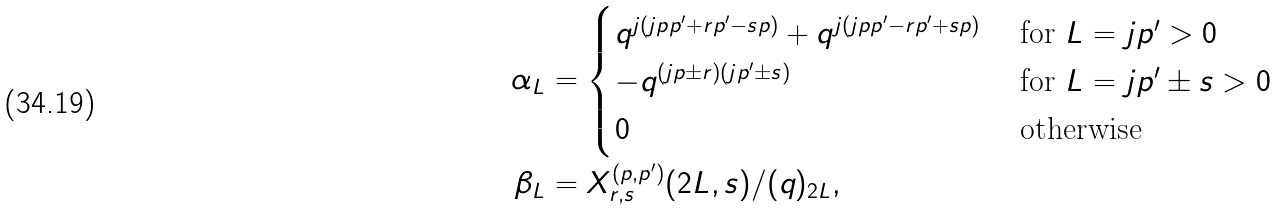Convert formula to latex. <formula><loc_0><loc_0><loc_500><loc_500>\alpha _ { L } & = \begin{cases} q ^ { j ( j p p ^ { \prime } + r p ^ { \prime } - s p ) } + q ^ { j ( j p p ^ { \prime } - r p ^ { \prime } + s p ) } & \text { for $L=jp^{\prime}>0$} \\ - q ^ { ( j p \pm r ) ( j p ^ { \prime } \pm s ) } & \text { for $L=jp^{\prime}\pm s>0$} \\ 0 & \text { otherwise} \end{cases} \\ \beta _ { L } & = X ^ { ( p , p ^ { \prime } ) } _ { r , s } ( 2 L , s ) / ( q ) _ { 2 L } ,</formula> 